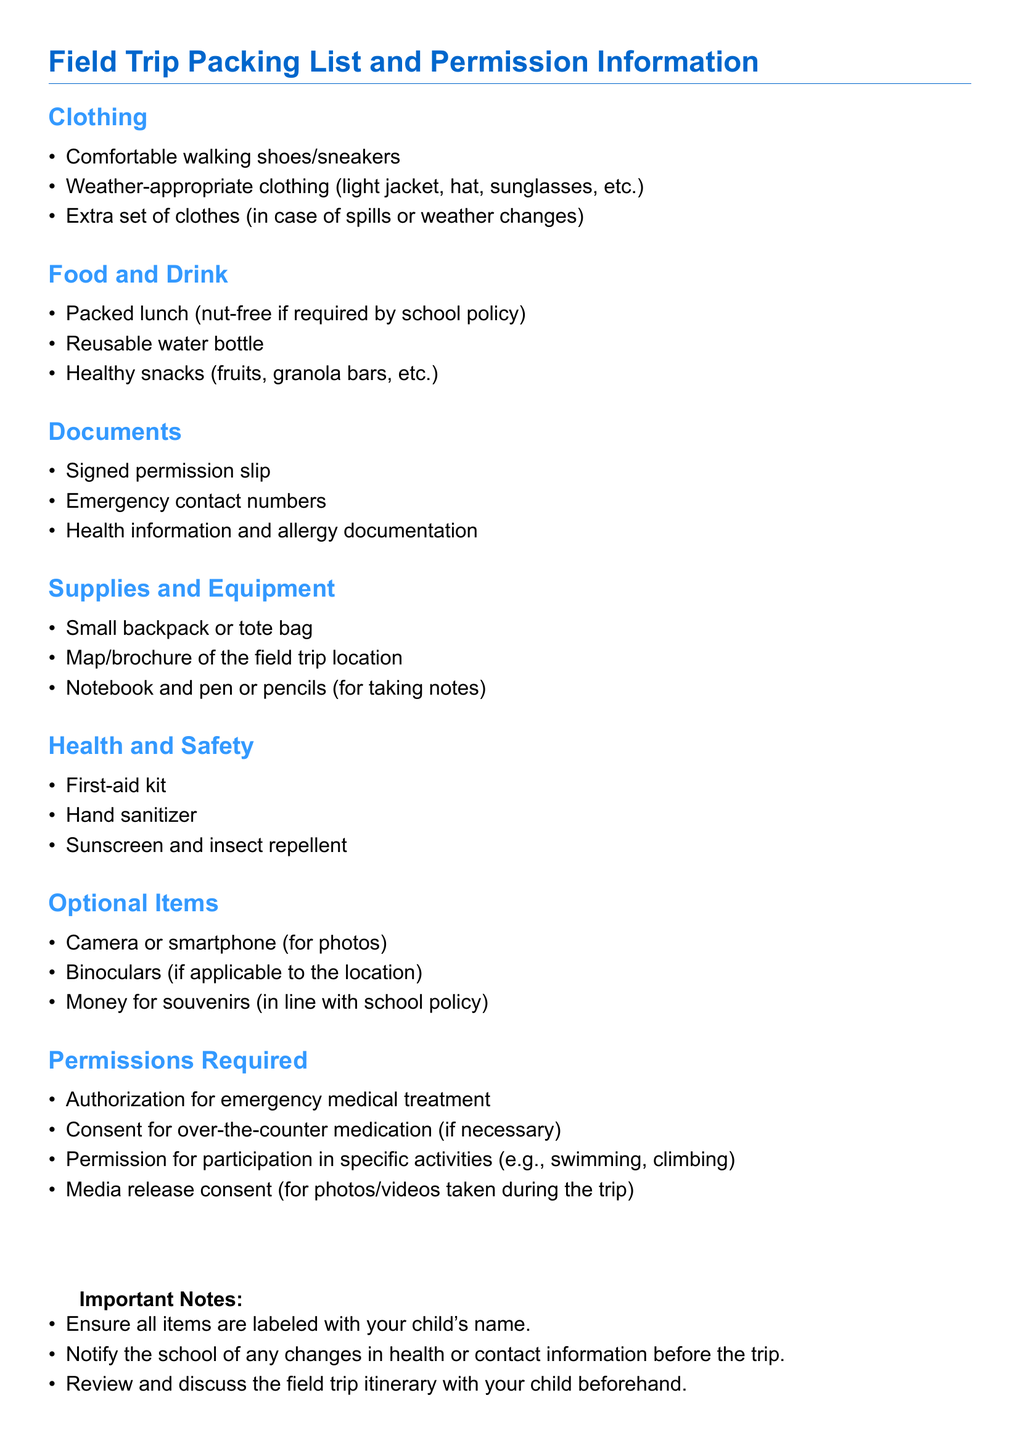What items are suggested for clothing? The document lists specific items under the clothing section which includes comfortable walking shoes, appropriate clothing based on weather, and an extra set of clothes.
Answer: Comfortable walking shoes, weather-appropriate clothing, extra set of clothes What should be packed for food and drink? The food and drink section mentions what to bring, including a packed lunch, a water bottle, and snacks.
Answer: Packed lunch, reusable water bottle, healthy snacks What type of documentation is required? The documents section specifies necessary paperwork, including a signed permission slip and emergency contact numbers.
Answer: Signed permission slip, emergency contact numbers, health information What health and safety item is included? The health and safety section lists items for maintaining safety and health, like a first-aid kit.
Answer: First-aid kit How many optional items are listed? The optional items section mentions three items that are not mandatory but suggested for the trip.
Answer: Three What is mentioned under permissions required? The document includes specific permissions that need to be obtained such as authorization for emergency medical treatment and consent for over-the-counter medication.
Answer: Authorization for emergency medical treatment, consent for over-the-counter medication What is one important note for parents? The important notes section provides several pieces of advice specifically for parents before the trip.
Answer: Ensure all items are labeled with your child's name What should be included for emergency contact? The documents section emphasizes the need for emergency contact numbers to be provided.
Answer: Emergency contact numbers 